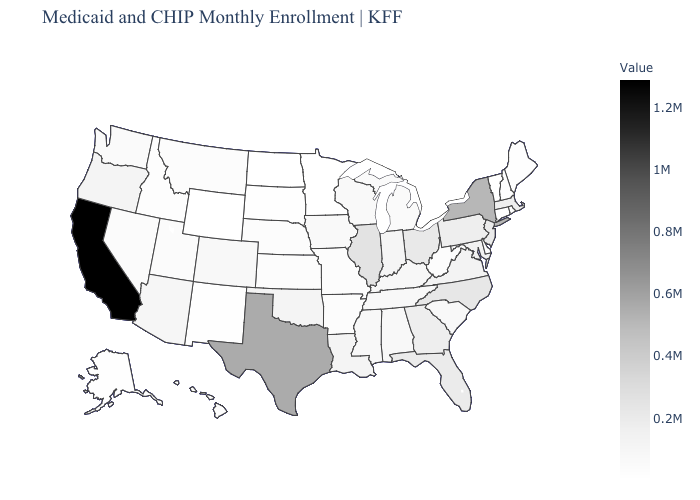Among the states that border Alabama , which have the lowest value?
Give a very brief answer. Tennessee. Which states have the highest value in the USA?
Answer briefly. California. Which states have the highest value in the USA?
Quick response, please. California. Which states have the lowest value in the USA?
Quick response, please. Minnesota. Does Idaho have the lowest value in the West?
Concise answer only. No. 